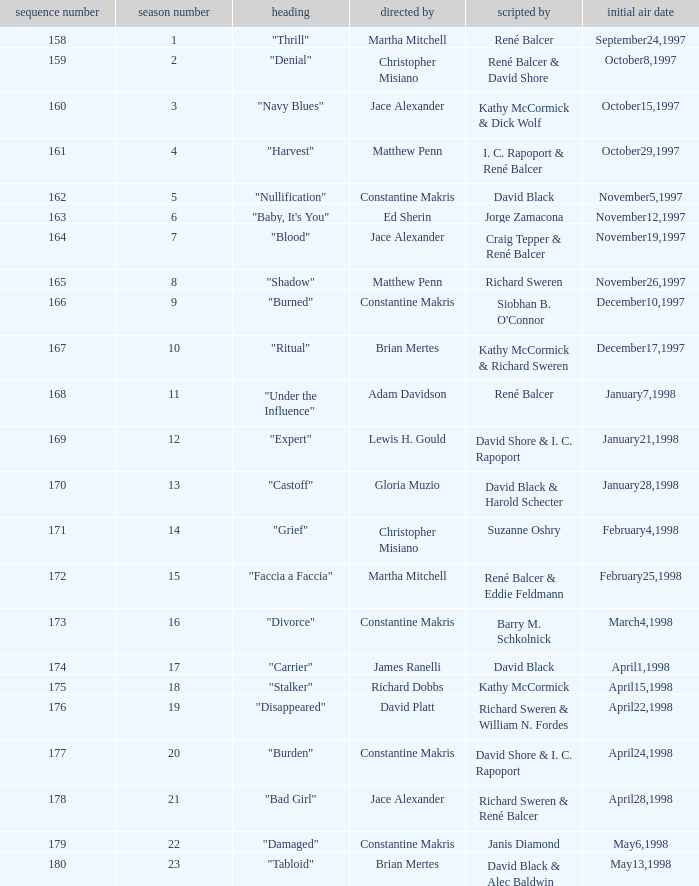Name the title of the episode that ed sherin directed. "Baby, It's You". 